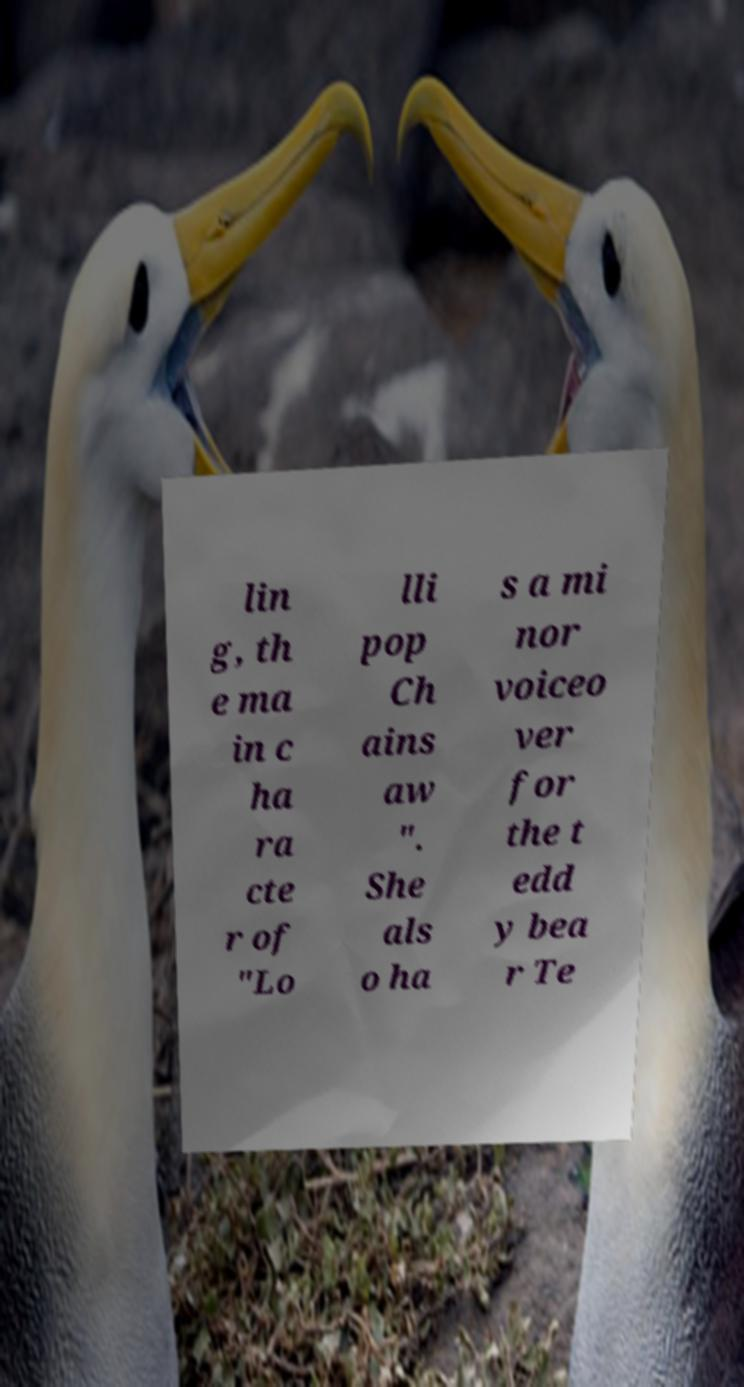For documentation purposes, I need the text within this image transcribed. Could you provide that? lin g, th e ma in c ha ra cte r of "Lo lli pop Ch ains aw ". She als o ha s a mi nor voiceo ver for the t edd y bea r Te 